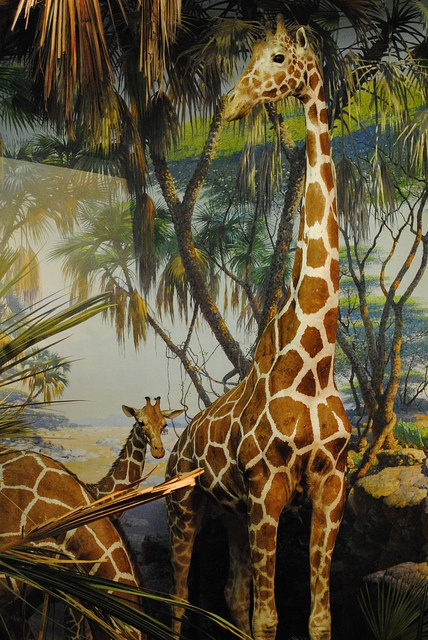Describe the objects in this image and their specific colors. I can see giraffe in maroon, olive, and black tones and giraffe in maroon, olive, and black tones in this image. 